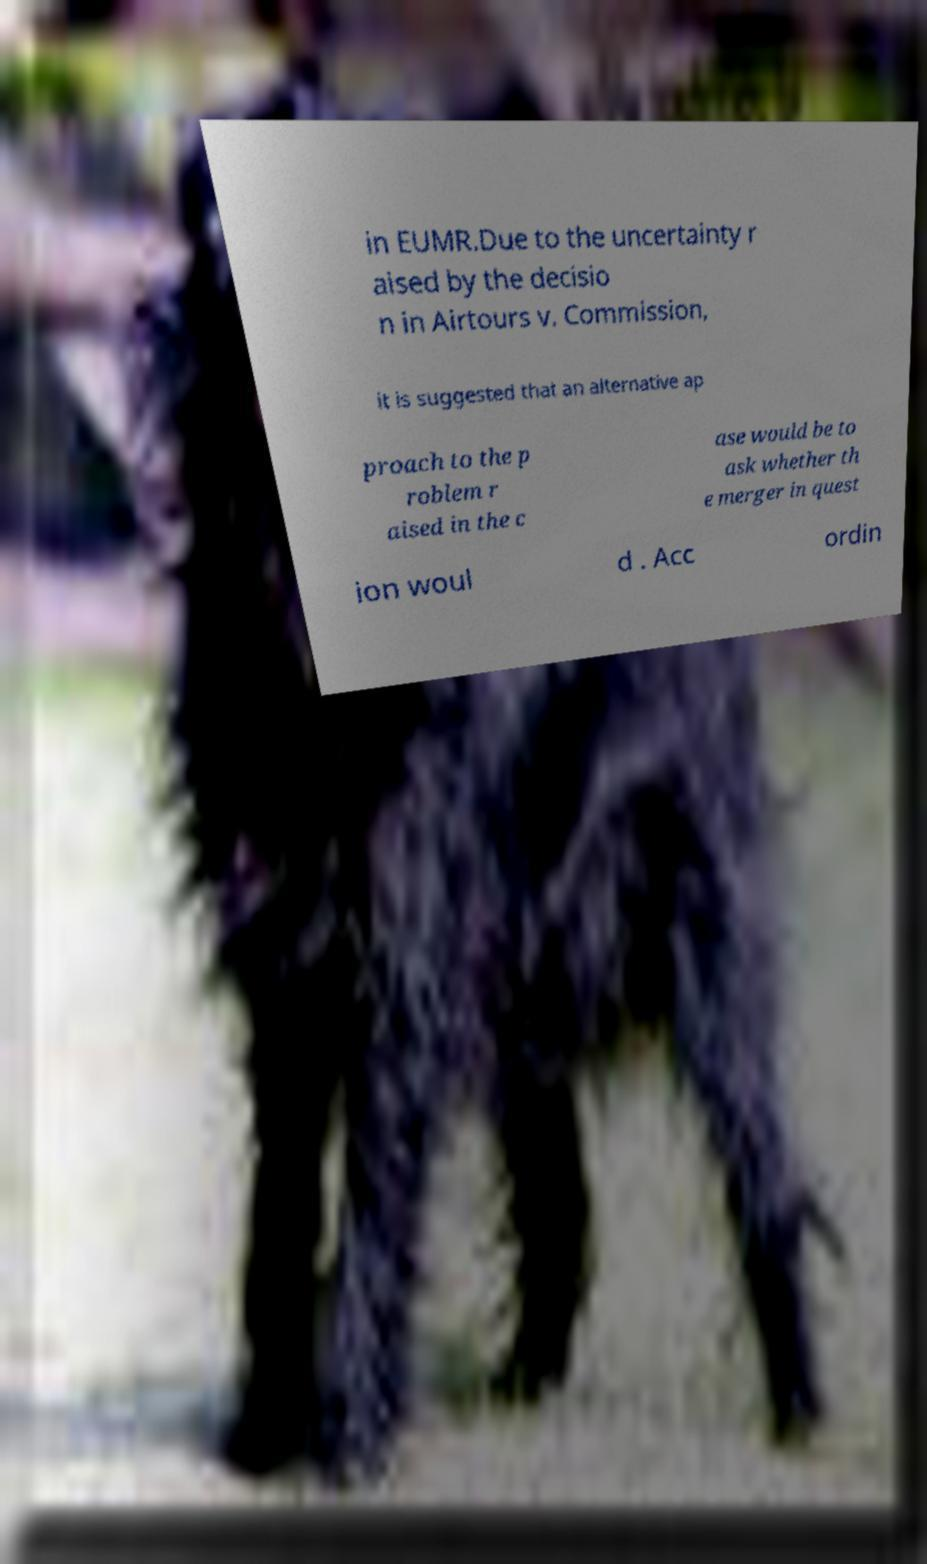Please identify and transcribe the text found in this image. in EUMR.Due to the uncertainty r aised by the decisio n in Airtours v. Commission, it is suggested that an alternative ap proach to the p roblem r aised in the c ase would be to ask whether th e merger in quest ion woul d . Acc ordin 